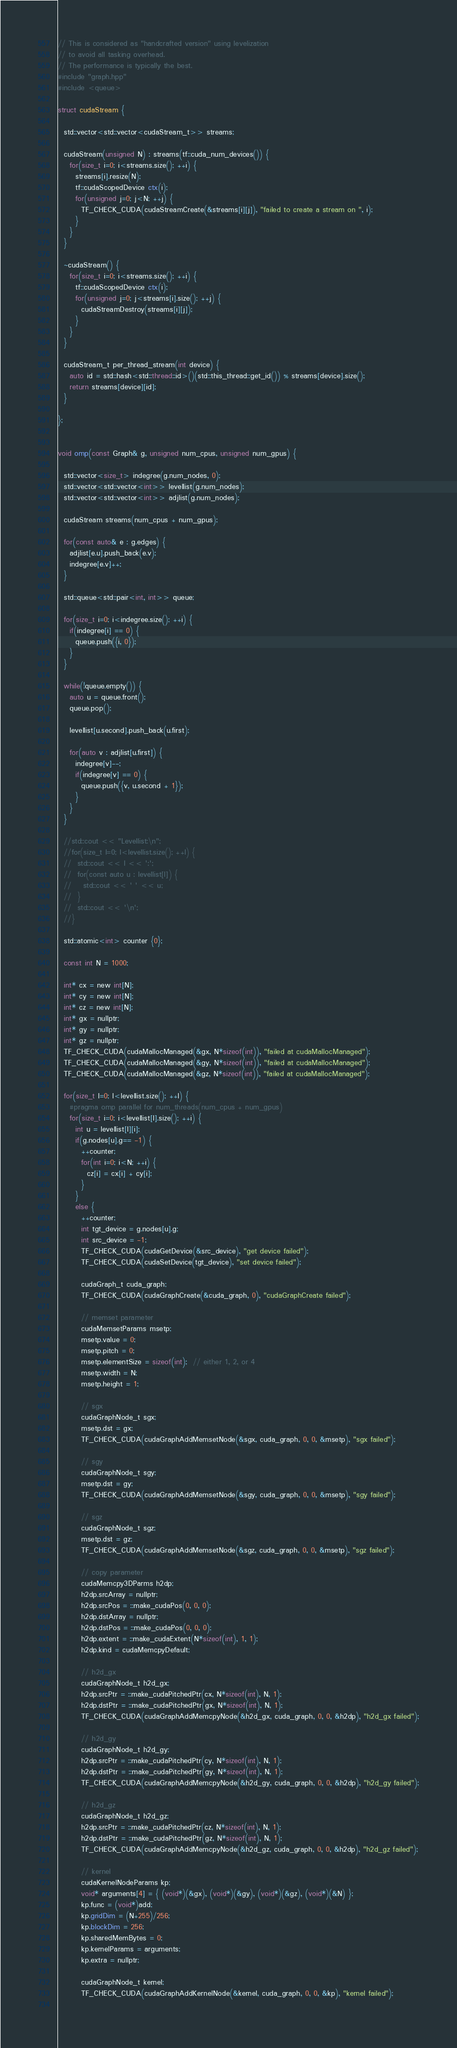<code> <loc_0><loc_0><loc_500><loc_500><_Cuda_>// This is considered as "handcrafted version" using levelization
// to avoid all tasking overhead. 
// The performance is typically the best.
#include "graph.hpp"
#include <queue>

struct cudaStream {

  std::vector<std::vector<cudaStream_t>> streams;

  cudaStream(unsigned N) : streams(tf::cuda_num_devices()) {
    for(size_t i=0; i<streams.size(); ++i) {
      streams[i].resize(N);
      tf::cudaScopedDevice ctx(i);
      for(unsigned j=0; j<N; ++j) {
        TF_CHECK_CUDA(cudaStreamCreate(&streams[i][j]), "failed to create a stream on ", i);
      }
    }
  }

  ~cudaStream() {
    for(size_t i=0; i<streams.size(); ++i) {
      tf::cudaScopedDevice ctx(i);
      for(unsigned j=0; j<streams[i].size(); ++j) {
        cudaStreamDestroy(streams[i][j]);
      }
    }
  }
  
  cudaStream_t per_thread_stream(int device) {
    auto id = std::hash<std::thread::id>()(std::this_thread::get_id()) % streams[device].size();
    return streams[device][id];
  }

};


void omp(const Graph& g, unsigned num_cpus, unsigned num_gpus) {

  std::vector<size_t> indegree(g.num_nodes, 0);
  std::vector<std::vector<int>> levellist(g.num_nodes);
  std::vector<std::vector<int>> adjlist(g.num_nodes);
  
  cudaStream streams(num_cpus + num_gpus);
  
  for(const auto& e : g.edges) {
    adjlist[e.u].push_back(e.v);
    indegree[e.v]++;
  }

  std::queue<std::pair<int, int>> queue;

  for(size_t i=0; i<indegree.size(); ++i) {
    if(indegree[i] == 0) {
      queue.push({i, 0});
    }
  }

  while(!queue.empty()) {
    auto u = queue.front();
    queue.pop();

    levellist[u.second].push_back(u.first);
    
    for(auto v : adjlist[u.first]) {
      indegree[v]--;
      if(indegree[v] == 0) {
        queue.push({v, u.second + 1});
      }
    }
  }

  //std::cout << "Levellist:\n";
  //for(size_t l=0; l<levellist.size(); ++l) {
  //  std::cout << l << ':';
  //  for(const auto u : levellist[l]) {
  //    std::cout << ' ' << u;
  //  }
  //  std::cout << '\n';
  //}
  
  std::atomic<int> counter {0};
  
  const int N = 1000;
  
  int* cx = new int[N];
  int* cy = new int[N];
  int* cz = new int[N];
  int* gx = nullptr;
  int* gy = nullptr;
  int* gz = nullptr;
  TF_CHECK_CUDA(cudaMallocManaged(&gx, N*sizeof(int)), "failed at cudaMallocManaged");
  TF_CHECK_CUDA(cudaMallocManaged(&gy, N*sizeof(int)), "failed at cudaMallocManaged");
  TF_CHECK_CUDA(cudaMallocManaged(&gz, N*sizeof(int)), "failed at cudaMallocManaged");
  
  for(size_t l=0; l<levellist.size(); ++l) {
    #pragma omp parallel for num_threads(num_cpus + num_gpus)
    for(size_t i=0; i<levellist[l].size(); ++i) {
      int u = levellist[l][i];
      if(g.nodes[u].g== -1) {
        ++counter;
        for(int i=0; i<N; ++i) {
          cz[i] = cx[i] + cy[i];
        }
      }
      else {
        ++counter;
        int tgt_device = g.nodes[u].g;
        int src_device = -1;
        TF_CHECK_CUDA(cudaGetDevice(&src_device), "get device failed");
        TF_CHECK_CUDA(cudaSetDevice(tgt_device), "set device failed");

        cudaGraph_t cuda_graph;
        TF_CHECK_CUDA(cudaGraphCreate(&cuda_graph, 0), "cudaGraphCreate failed");

        // memset parameter
        cudaMemsetParams msetp;
        msetp.value = 0;
        msetp.pitch = 0;
        msetp.elementSize = sizeof(int);  // either 1, 2, or 4
        msetp.width = N;
        msetp.height = 1;

        // sgx
        cudaGraphNode_t sgx;
        msetp.dst = gx;
        TF_CHECK_CUDA(cudaGraphAddMemsetNode(&sgx, cuda_graph, 0, 0, &msetp), "sgx failed");
        
        // sgy
        cudaGraphNode_t sgy;
        msetp.dst = gy;
        TF_CHECK_CUDA(cudaGraphAddMemsetNode(&sgy, cuda_graph, 0, 0, &msetp), "sgy failed");
        
        // sgz
        cudaGraphNode_t sgz;
        msetp.dst = gz;
        TF_CHECK_CUDA(cudaGraphAddMemsetNode(&sgz, cuda_graph, 0, 0, &msetp), "sgz failed");
      
        // copy parameter
        cudaMemcpy3DParms h2dp;
        h2dp.srcArray = nullptr;
        h2dp.srcPos = ::make_cudaPos(0, 0, 0);
        h2dp.dstArray = nullptr;
        h2dp.dstPos = ::make_cudaPos(0, 0, 0);
        h2dp.extent = ::make_cudaExtent(N*sizeof(int), 1, 1);
        h2dp.kind = cudaMemcpyDefault;

        // h2d_gx
        cudaGraphNode_t h2d_gx;
        h2dp.srcPtr = ::make_cudaPitchedPtr(cx, N*sizeof(int), N, 1);
        h2dp.dstPtr = ::make_cudaPitchedPtr(gx, N*sizeof(int), N, 1);
        TF_CHECK_CUDA(cudaGraphAddMemcpyNode(&h2d_gx, cuda_graph, 0, 0, &h2dp), "h2d_gx failed");

        // h2d_gy
        cudaGraphNode_t h2d_gy;
        h2dp.srcPtr = ::make_cudaPitchedPtr(cy, N*sizeof(int), N, 1);
        h2dp.dstPtr = ::make_cudaPitchedPtr(gy, N*sizeof(int), N, 1);
        TF_CHECK_CUDA(cudaGraphAddMemcpyNode(&h2d_gy, cuda_graph, 0, 0, &h2dp), "h2d_gy failed");

        // h2d_gz
        cudaGraphNode_t h2d_gz;
        h2dp.srcPtr = ::make_cudaPitchedPtr(cz, N*sizeof(int), N, 1);
        h2dp.dstPtr = ::make_cudaPitchedPtr(gz, N*sizeof(int), N, 1);
        TF_CHECK_CUDA(cudaGraphAddMemcpyNode(&h2d_gz, cuda_graph, 0, 0, &h2dp), "h2d_gz failed");
      
        // kernel
        cudaKernelNodeParams kp;
        void* arguments[4] = { (void*)(&gx), (void*)(&gy), (void*)(&gz), (void*)(&N) };
        kp.func = (void*)add;
        kp.gridDim = (N+255)/256;
        kp.blockDim = 256;
        kp.sharedMemBytes = 0;
        kp.kernelParams = arguments;
        kp.extra = nullptr;
        
        cudaGraphNode_t kernel;
        TF_CHECK_CUDA(cudaGraphAddKernelNode(&kernel, cuda_graph, 0, 0, &kp), "kernel failed");
        </code> 